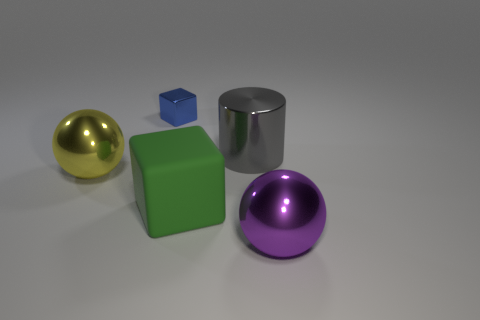There is a gray shiny thing that is to the right of the small blue thing; does it have the same shape as the shiny object behind the big gray metal object? The gray shiny object to the right of the small blue cube does not have the same shape as the shiny object behind the larger gray metallic cylinder. The object on the right is a cylindrical shape, whereas the shiny object in the background is a sphere. 